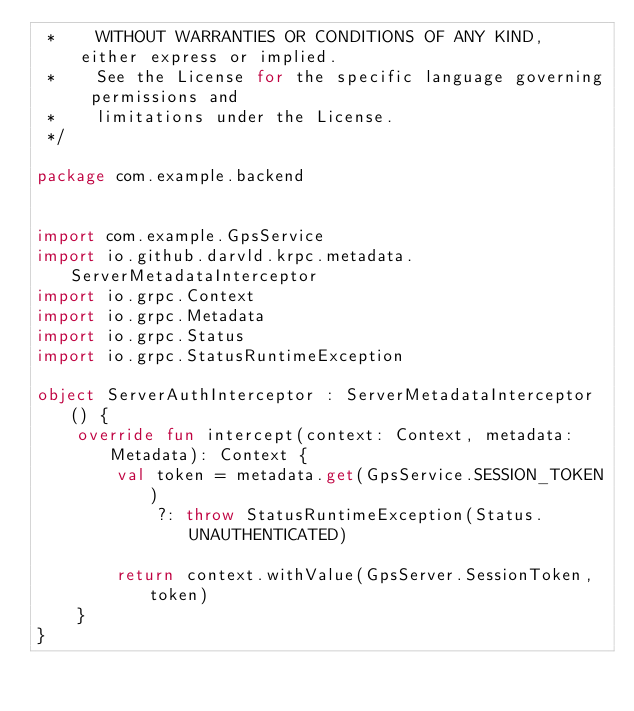<code> <loc_0><loc_0><loc_500><loc_500><_Kotlin_> *    WITHOUT WARRANTIES OR CONDITIONS OF ANY KIND, either express or implied.
 *    See the License for the specific language governing permissions and
 *    limitations under the License.
 */

package com.example.backend


import com.example.GpsService
import io.github.darvld.krpc.metadata.ServerMetadataInterceptor
import io.grpc.Context
import io.grpc.Metadata
import io.grpc.Status
import io.grpc.StatusRuntimeException

object ServerAuthInterceptor : ServerMetadataInterceptor() {
    override fun intercept(context: Context, metadata: Metadata): Context {
        val token = metadata.get(GpsService.SESSION_TOKEN)
            ?: throw StatusRuntimeException(Status.UNAUTHENTICATED)

        return context.withValue(GpsServer.SessionToken, token)
    }
}

</code> 